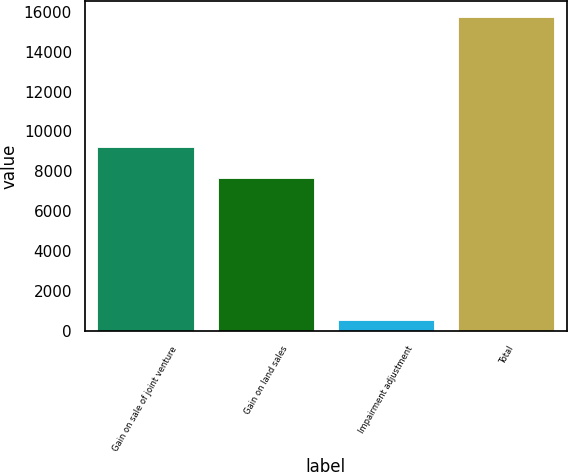Convert chart. <chart><loc_0><loc_0><loc_500><loc_500><bar_chart><fcel>Gain on sale of joint venture<fcel>Gain on land sales<fcel>Impairment adjustment<fcel>Total<nl><fcel>9214.2<fcel>7695<fcel>560<fcel>15752<nl></chart> 